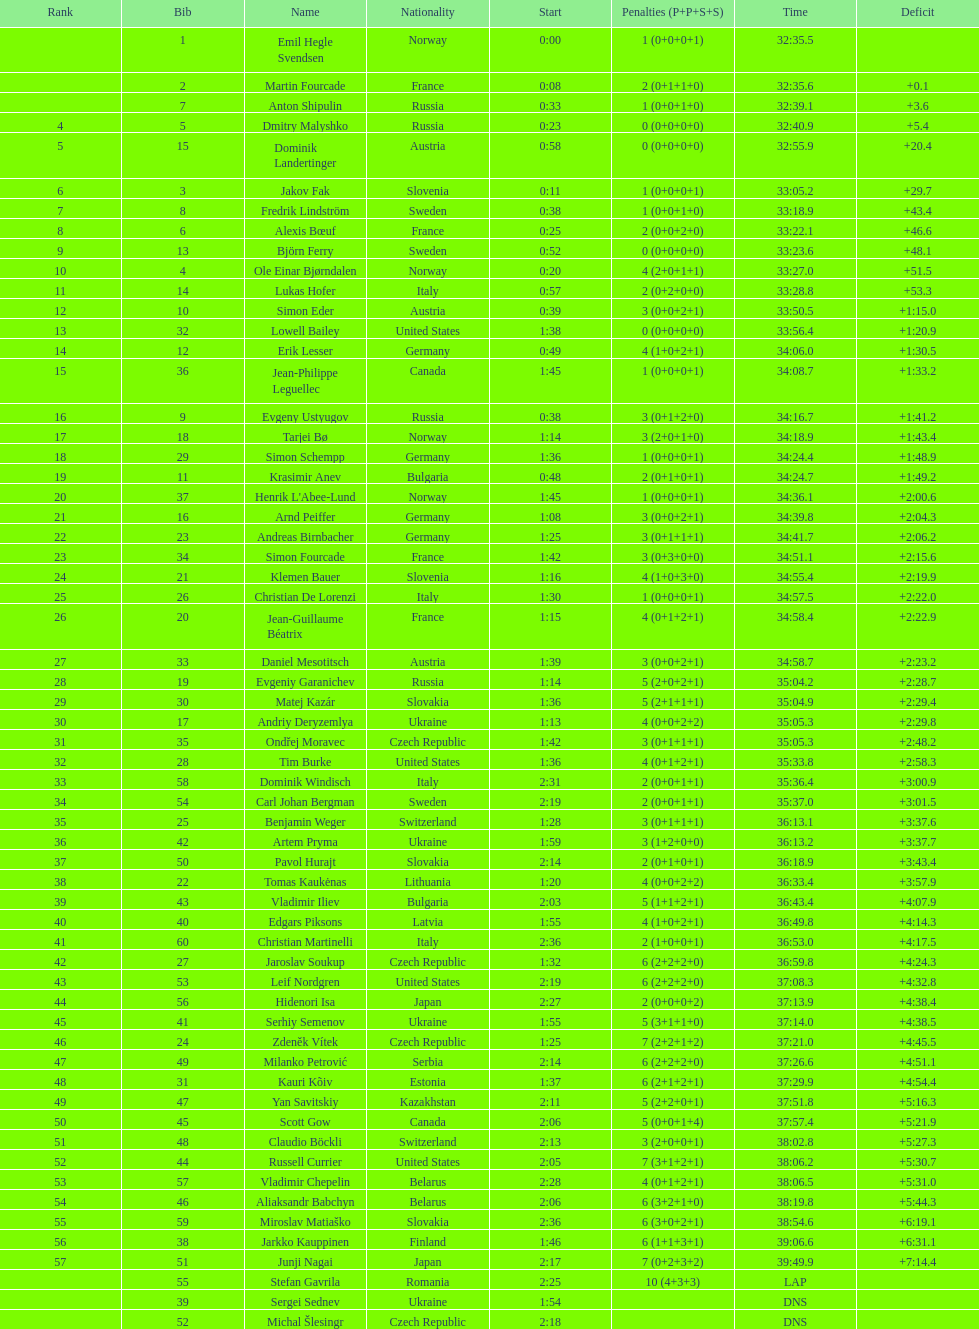What was the duration of erik lesser's completion? 34:06.0. 